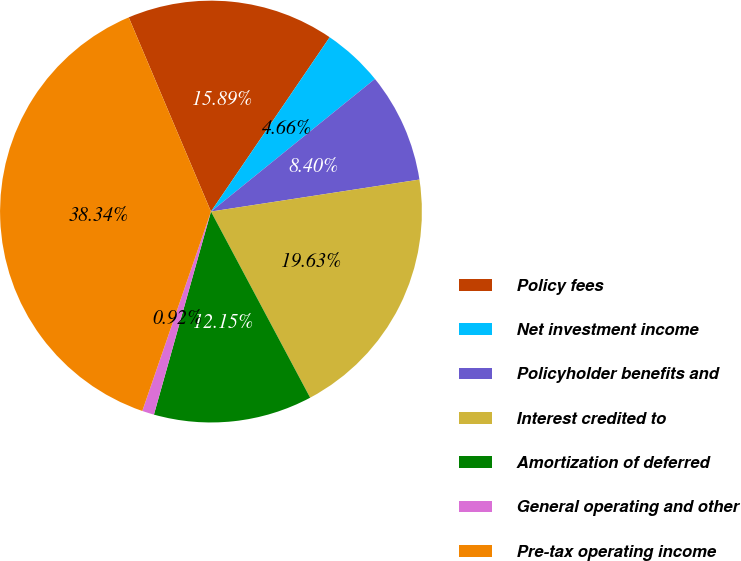Convert chart to OTSL. <chart><loc_0><loc_0><loc_500><loc_500><pie_chart><fcel>Policy fees<fcel>Net investment income<fcel>Policyholder benefits and<fcel>Interest credited to<fcel>Amortization of deferred<fcel>General operating and other<fcel>Pre-tax operating income<nl><fcel>15.89%<fcel>4.66%<fcel>8.4%<fcel>19.63%<fcel>12.15%<fcel>0.92%<fcel>38.34%<nl></chart> 